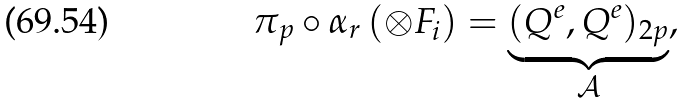Convert formula to latex. <formula><loc_0><loc_0><loc_500><loc_500>\pi _ { p } \circ \alpha _ { r } \, ( \otimes F _ { i } ) = \underbrace { ( Q ^ { e } , Q ^ { e } ) _ { 2 p } } _ { \mathcal { A } } ,</formula> 